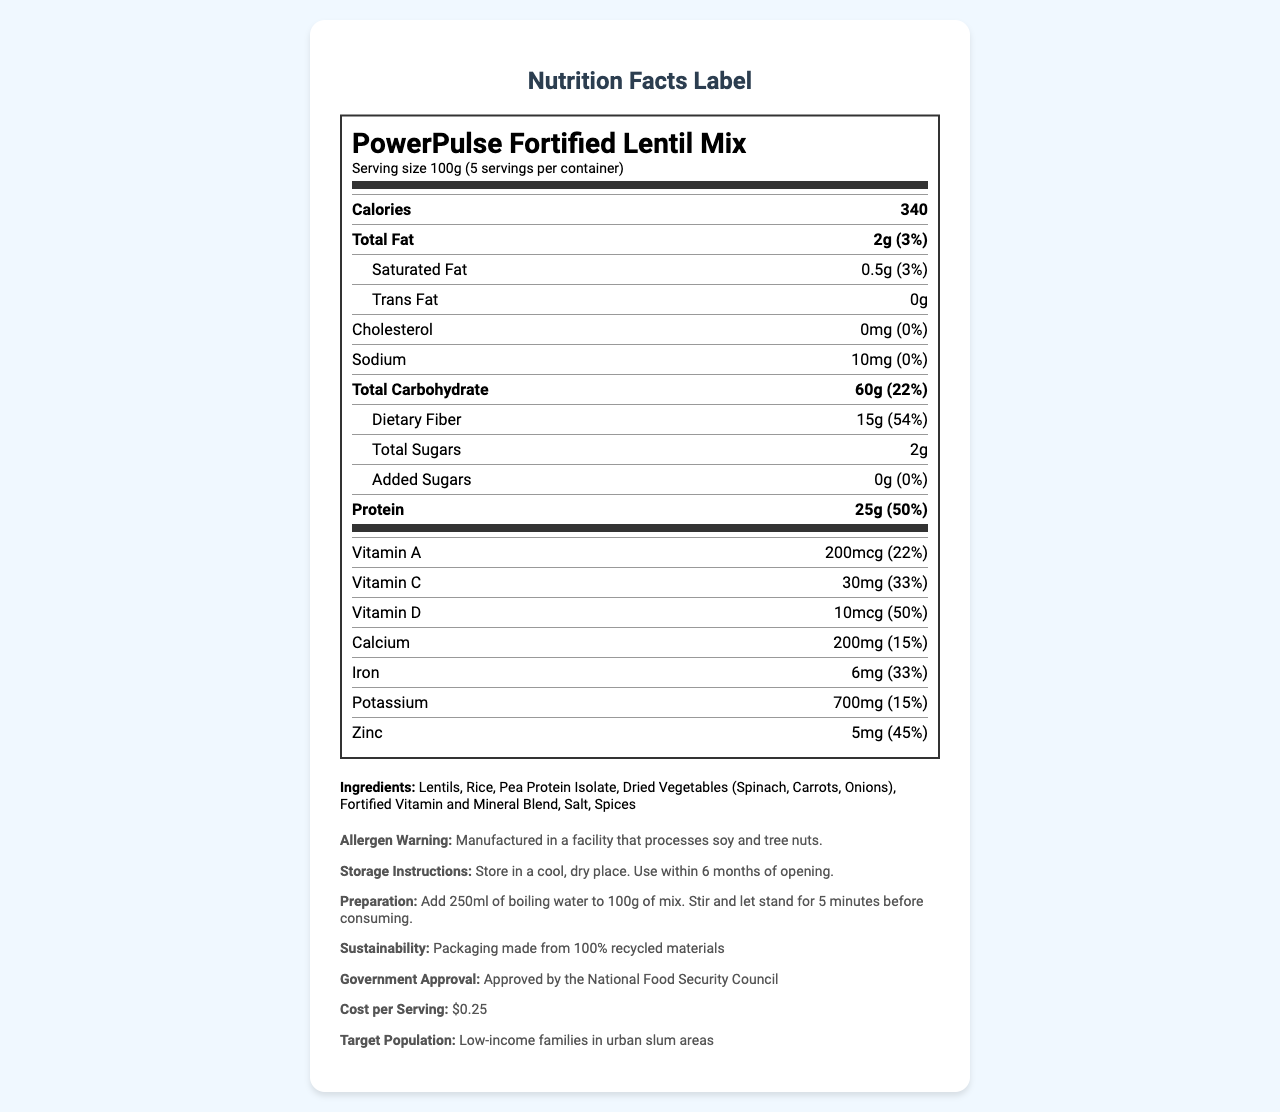what is the serving size? The serving size is prominently listed at the top of the nutrition facts under the product name.
Answer: 100g how many calories are there per serving? The number of calories per serving is listed as 340 in the nutrition facts section.
Answer: 340 how much protein is in one serving? The protein content is clearly mentioned in the nutrition facts, showing 25g per serving.
Answer: 25g what is the percentage of daily value of dietary fiber per serving? The daily value percentage for dietary fiber is listed as 54% in the nutrition facts.
Answer: 54% are there any trans fats in the product? The nutrition facts label indicates 0g of trans fats in the product.
Answer: No A. Vitamin A
B. Vitamin C
C. Vitamin D Vitamin D has a daily percentage value of 50%, which is higher compared to Vitamin A (22%) and Vitamin C (33%).
Answer: C I. Lentils
II. Rice
III. Pea Protein Isolate
IV. Dried Vegetables Lentils are listed first in the ingredients list.
Answer: I is this product suitable for individuals with soy allergies? The allergen warning states that the product is manufactured in a facility that processes soy and tree nuts.
Answer: No summarize the main purpose of this document. The document contains comprehensive information about the product, nutritional content, ingredients, warnings, storage, preparation, and distribution to support low-income families suffering from food insecurity.
Answer: The document provides the nutrition facts and additional details for the "PowerPulse Fortified Lentil Mix", a cost-effective, high-protein food product designed to address food insecurity in urban slums. It includes nutritional information, ingredients, allergen warnings, storage and preparation instructions, and details about government approval and distribution partners. how many families have been reached by this product? The impact metrics section indicates that 500,000 families have been reached by this product.
Answer: 500,000 what is the cost per serving of the product? The cost per serving is explicitly mentioned as $0.25 in the additional information section.
Answer: $0.25 what is the servings per container? The serving size details mention that there are 5 servings per container.
Answer: 5 are the vitamins in this product adequate to address common deficiencies? The product is fortified with essential vitamins and minerals, as indicated in its nutritional benefits, making it suitable to address common deficiencies.
Answer: Yes can the exact amount of each spice used be determined from the document? The ingredient list includes "Spices" generically, but it does not specify the exact types or amounts of each spice used in the mix.
Answer: Not enough information 